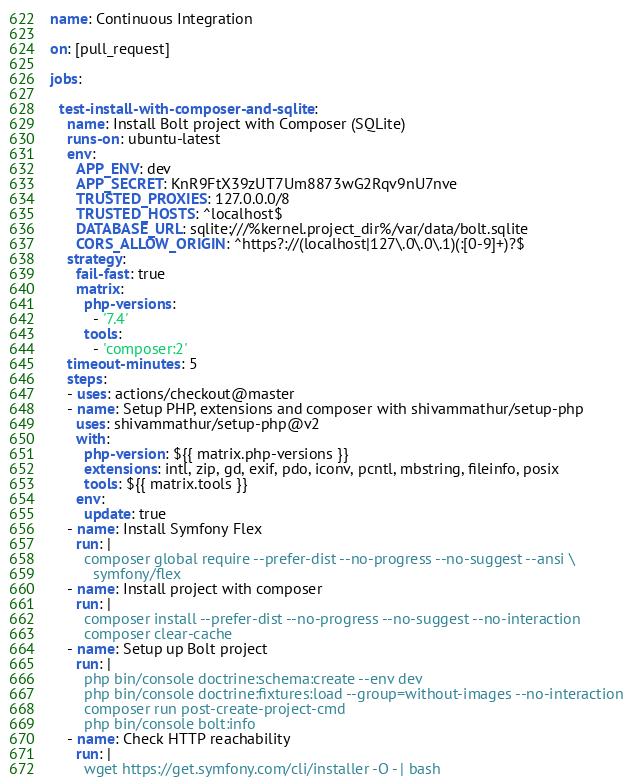<code> <loc_0><loc_0><loc_500><loc_500><_YAML_>name: Continuous Integration

on: [pull_request]

jobs:

  test-install-with-composer-and-sqlite:
    name: Install Bolt project with Composer (SQLite)
    runs-on: ubuntu-latest
    env:
      APP_ENV: dev
      APP_SECRET: KnR9FtX39zUT7Um8873wG2Rqv9nU7nve
      TRUSTED_PROXIES: 127.0.0.0/8
      TRUSTED_HOSTS: ^localhost$
      DATABASE_URL: sqlite:///%kernel.project_dir%/var/data/bolt.sqlite
      CORS_ALLOW_ORIGIN: ^https?://(localhost|127\.0\.0\.1)(:[0-9]+)?$
    strategy:
      fail-fast: true
      matrix:
        php-versions:
          - '7.4'
        tools:
          - 'composer:2'
    timeout-minutes: 5
    steps:
    - uses: actions/checkout@master
    - name: Setup PHP, extensions and composer with shivammathur/setup-php
      uses: shivammathur/setup-php@v2
      with:
        php-version: ${{ matrix.php-versions }}
        extensions: intl, zip, gd, exif, pdo, iconv, pcntl, mbstring, fileinfo, posix
        tools: ${{ matrix.tools }}
      env:
        update: true
    - name: Install Symfony Flex
      run: |
        composer global require --prefer-dist --no-progress --no-suggest --ansi \
          symfony/flex
    - name: Install project with composer
      run: |
        composer install --prefer-dist --no-progress --no-suggest --no-interaction
        composer clear-cache
    - name: Setup up Bolt project
      run: |
        php bin/console doctrine:schema:create --env dev
        php bin/console doctrine:fixtures:load --group=without-images --no-interaction
        composer run post-create-project-cmd
        php bin/console bolt:info
    - name: Check HTTP reachability
      run: |
        wget https://get.symfony.com/cli/installer -O - | bash</code> 